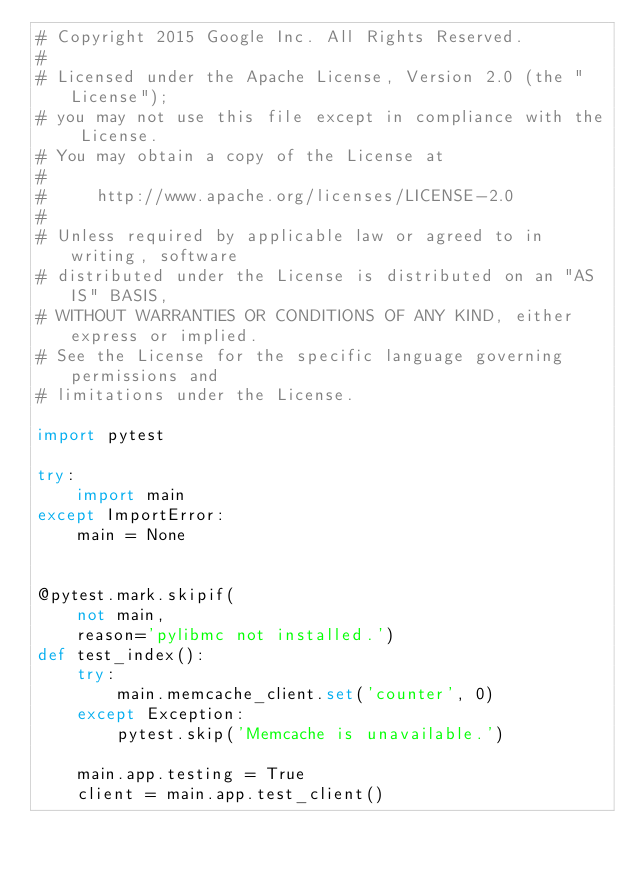Convert code to text. <code><loc_0><loc_0><loc_500><loc_500><_Python_># Copyright 2015 Google Inc. All Rights Reserved.
#
# Licensed under the Apache License, Version 2.0 (the "License");
# you may not use this file except in compliance with the License.
# You may obtain a copy of the License at
#
#     http://www.apache.org/licenses/LICENSE-2.0
#
# Unless required by applicable law or agreed to in writing, software
# distributed under the License is distributed on an "AS IS" BASIS,
# WITHOUT WARRANTIES OR CONDITIONS OF ANY KIND, either express or implied.
# See the License for the specific language governing permissions and
# limitations under the License.

import pytest

try:
    import main
except ImportError:
    main = None


@pytest.mark.skipif(
    not main,
    reason='pylibmc not installed.')
def test_index():
    try:
        main.memcache_client.set('counter', 0)
    except Exception:
        pytest.skip('Memcache is unavailable.')

    main.app.testing = True
    client = main.app.test_client()
</code> 